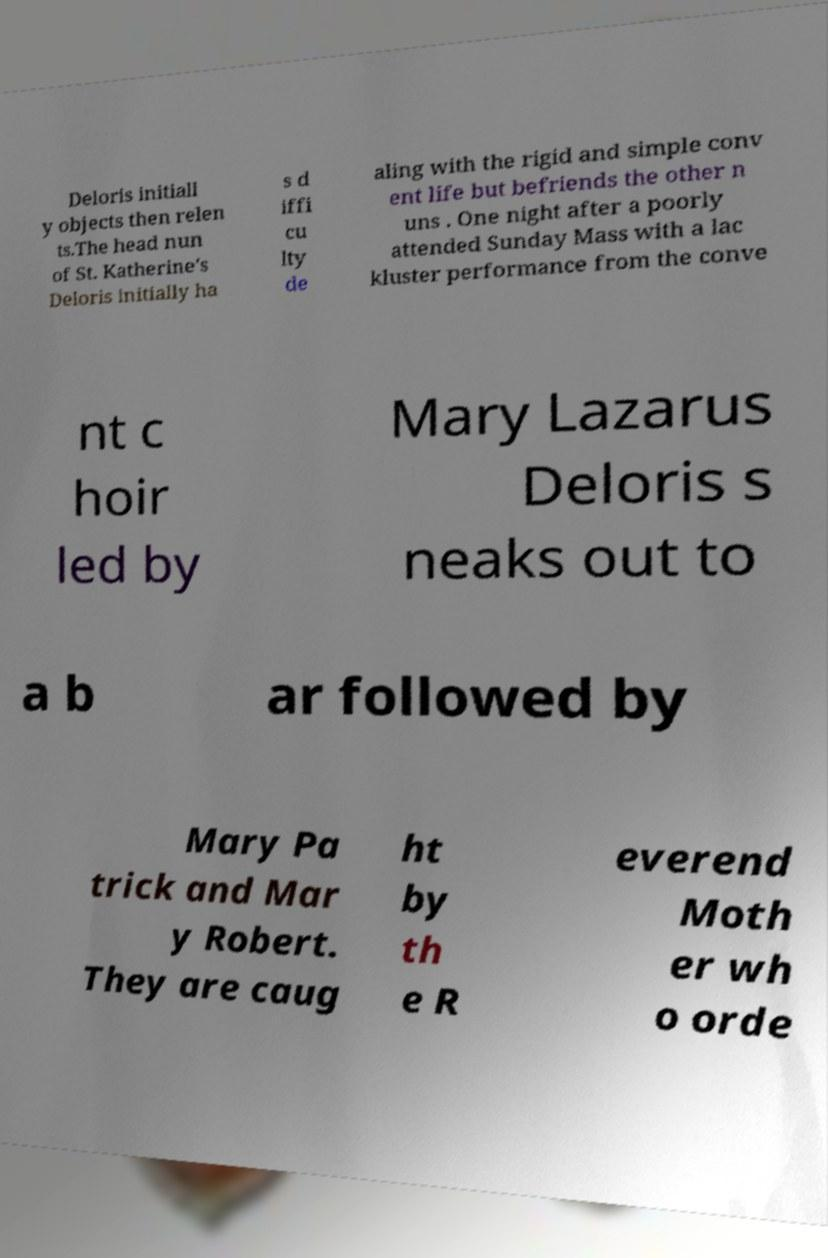Please read and relay the text visible in this image. What does it say? Deloris initiall y objects then relen ts.The head nun of St. Katherine's Deloris initially ha s d iffi cu lty de aling with the rigid and simple conv ent life but befriends the other n uns . One night after a poorly attended Sunday Mass with a lac kluster performance from the conve nt c hoir led by Mary Lazarus Deloris s neaks out to a b ar followed by Mary Pa trick and Mar y Robert. They are caug ht by th e R everend Moth er wh o orde 